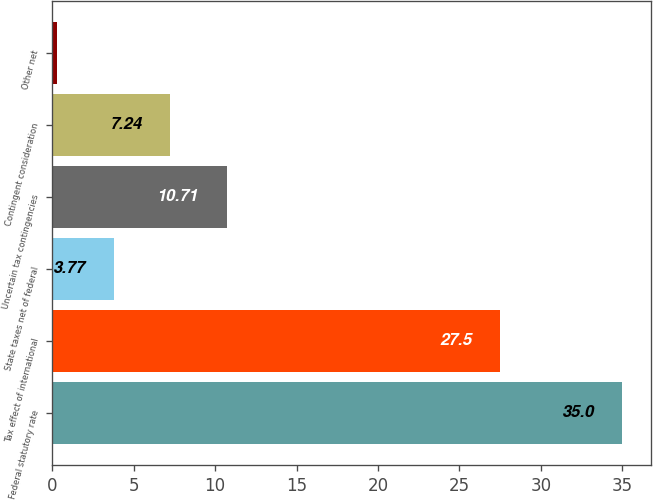Convert chart to OTSL. <chart><loc_0><loc_0><loc_500><loc_500><bar_chart><fcel>Federal statutory rate<fcel>Tax effect of international<fcel>State taxes net of federal<fcel>Uncertain tax contingencies<fcel>Contingent consideration<fcel>Other net<nl><fcel>35<fcel>27.5<fcel>3.77<fcel>10.71<fcel>7.24<fcel>0.3<nl></chart> 